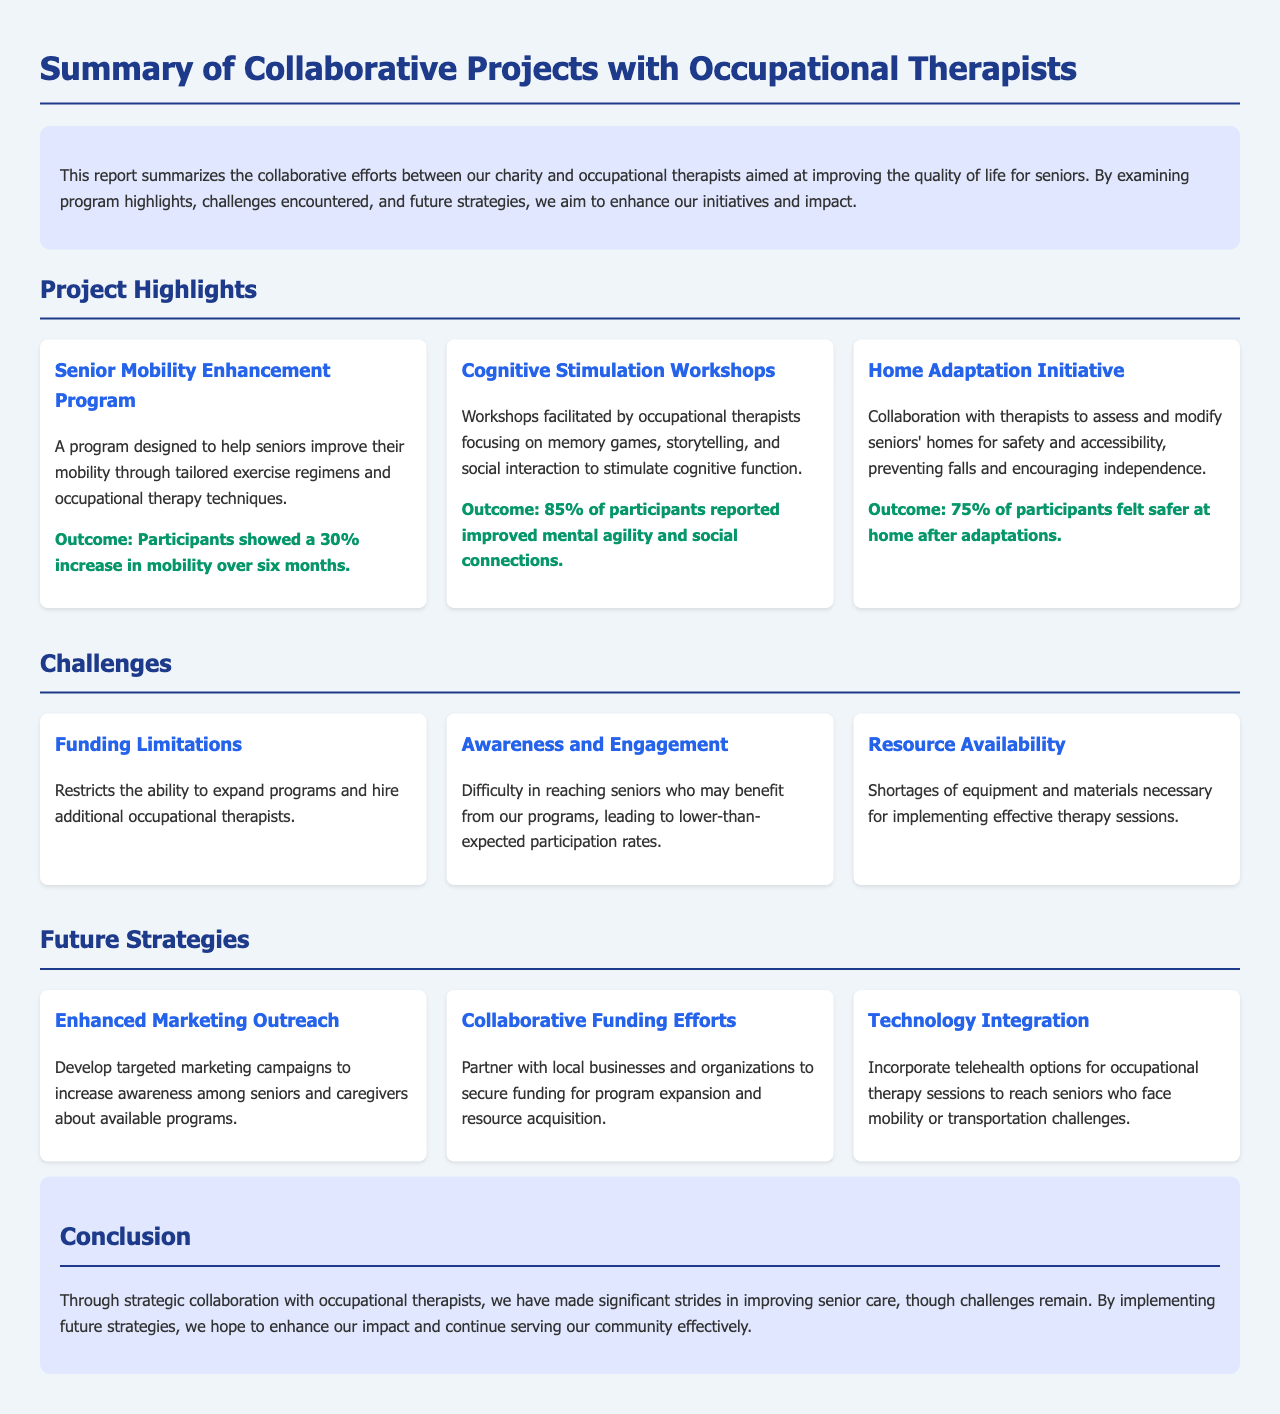What is the title of the report? The title is stated at the beginning of the document, which summarizes the collaborative efforts.
Answer: Summary of Collaborative Projects with Occupational Therapists What program had a 30% increase in mobility? The document highlights several programs, one of which specifically mentions the outcome related to mobility improvement.
Answer: Senior Mobility Enhancement Program What percentage of participants reported improved mental agility? The report includes statistics on workshop outcomes, revealing a particular level of participant improvement.
Answer: 85% Which challenge involves reaching potential beneficiaries? The challenges section mentions difficulties in engagement related to participants for programs.
Answer: Awareness and Engagement What strategy focuses on partnering for funding? A future strategy discusses collaborating with other entities to enhance resources and program scope.
Answer: Collaborative Funding Efforts What was the outcome for participants feeling safer at home after adaptations? The report quantifies the impact of home safety modifications among participants.
Answer: 75% What is one method proposed to overcome mobility challenges for seniors? The strategies outlined include technological solutions to improve access to therapy services.
Answer: Technology Integration What color is used for the project titles? The document employs specific styling choices to enhance visibility and organization.
Answer: Blue 